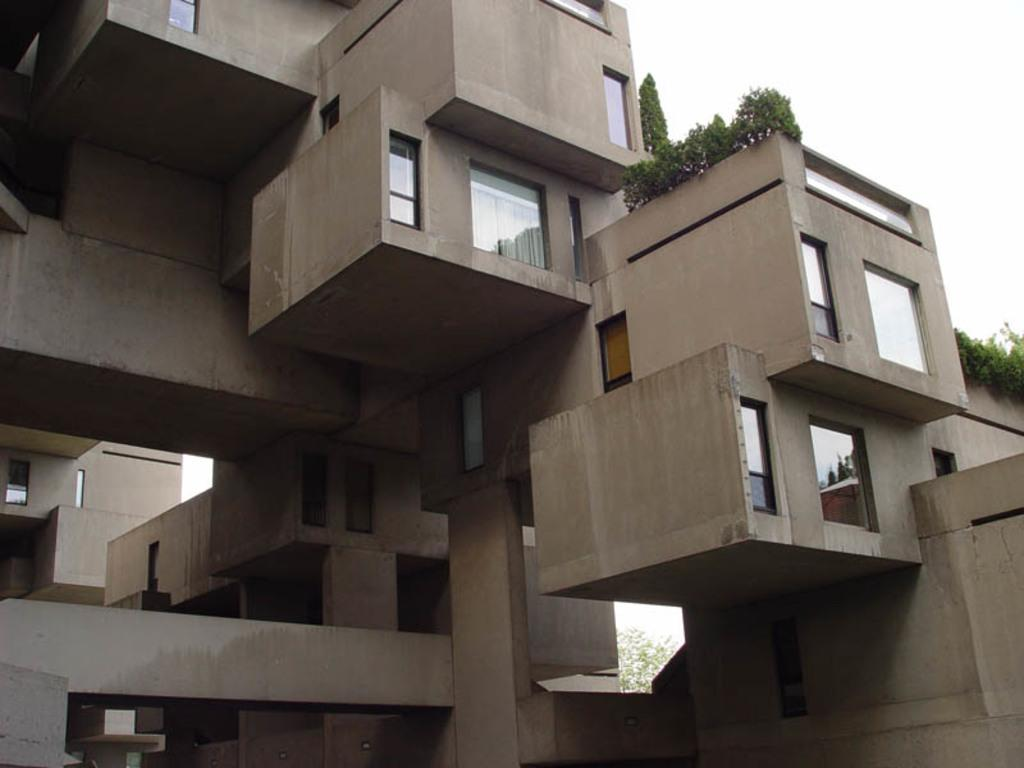What type of structure is present in the image? There is a building in the image. Are there any other objects or features in the image besides the building? Yes, there is a house plant in the image. What part of the building is visible in the image? The building has a window. What type of learning is taking place in the image? There is no indication of any learning taking place in the image. 